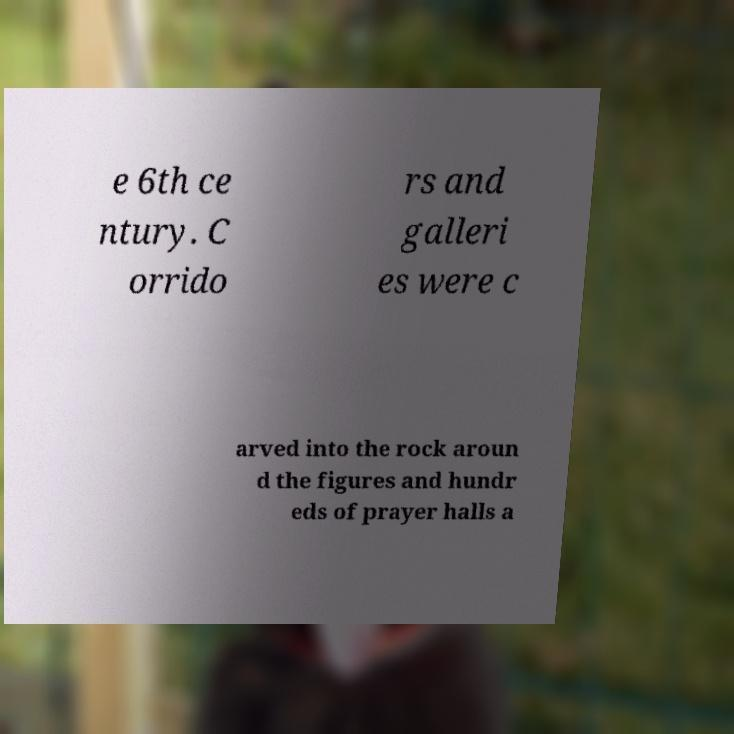I need the written content from this picture converted into text. Can you do that? e 6th ce ntury. C orrido rs and galleri es were c arved into the rock aroun d the figures and hundr eds of prayer halls a 